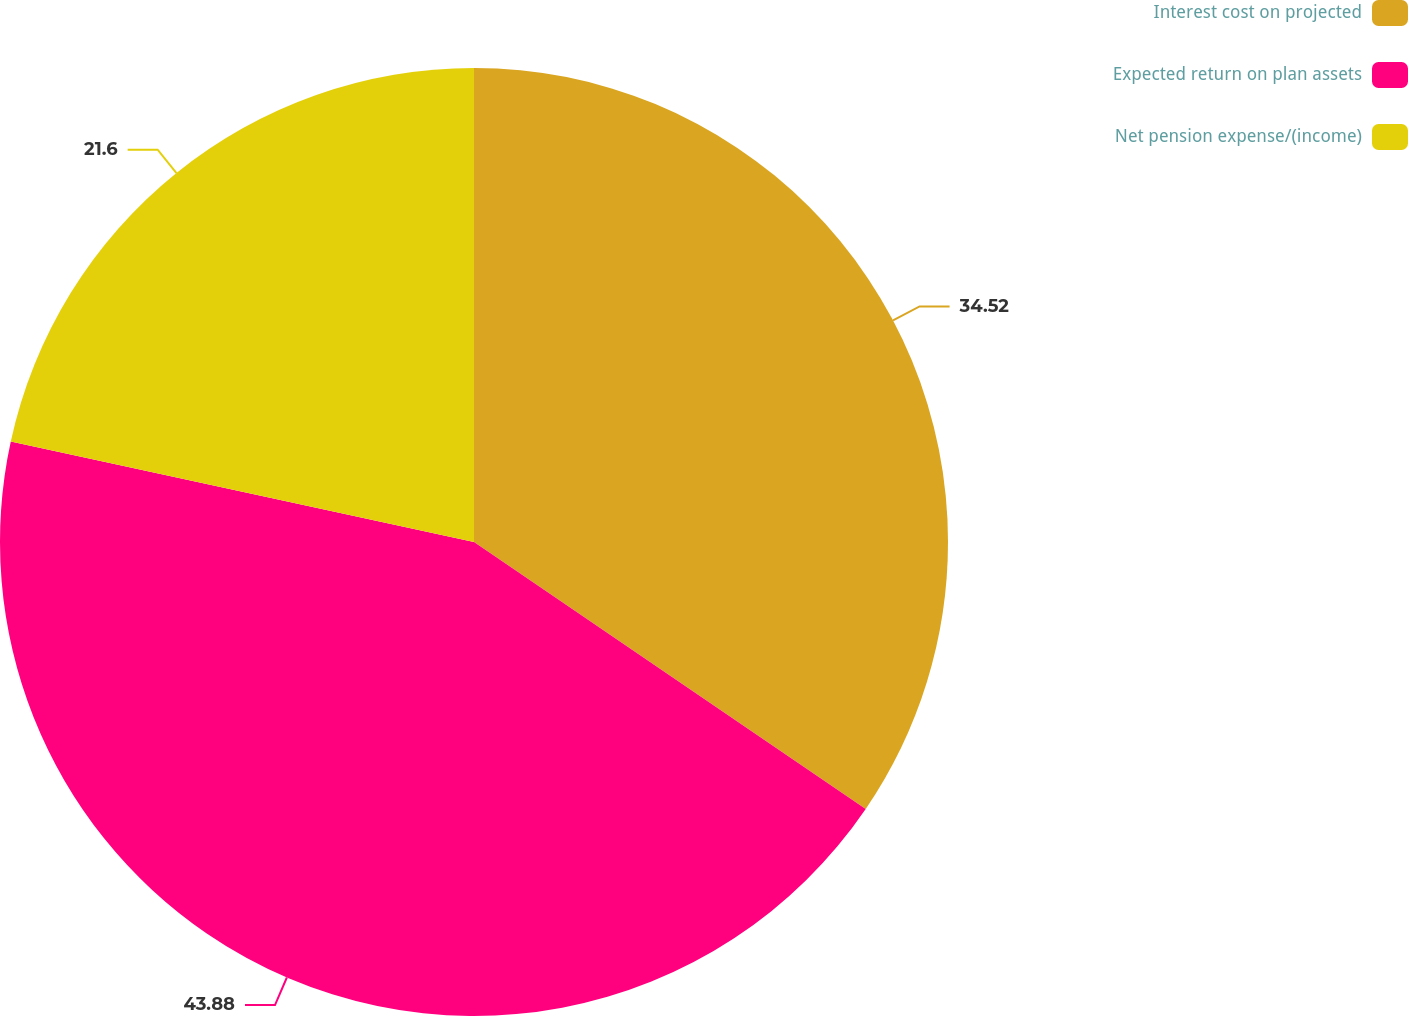Convert chart. <chart><loc_0><loc_0><loc_500><loc_500><pie_chart><fcel>Interest cost on projected<fcel>Expected return on plan assets<fcel>Net pension expense/(income)<nl><fcel>34.52%<fcel>43.88%<fcel>21.6%<nl></chart> 